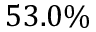<formula> <loc_0><loc_0><loc_500><loc_500>5 3 . 0 \%</formula> 